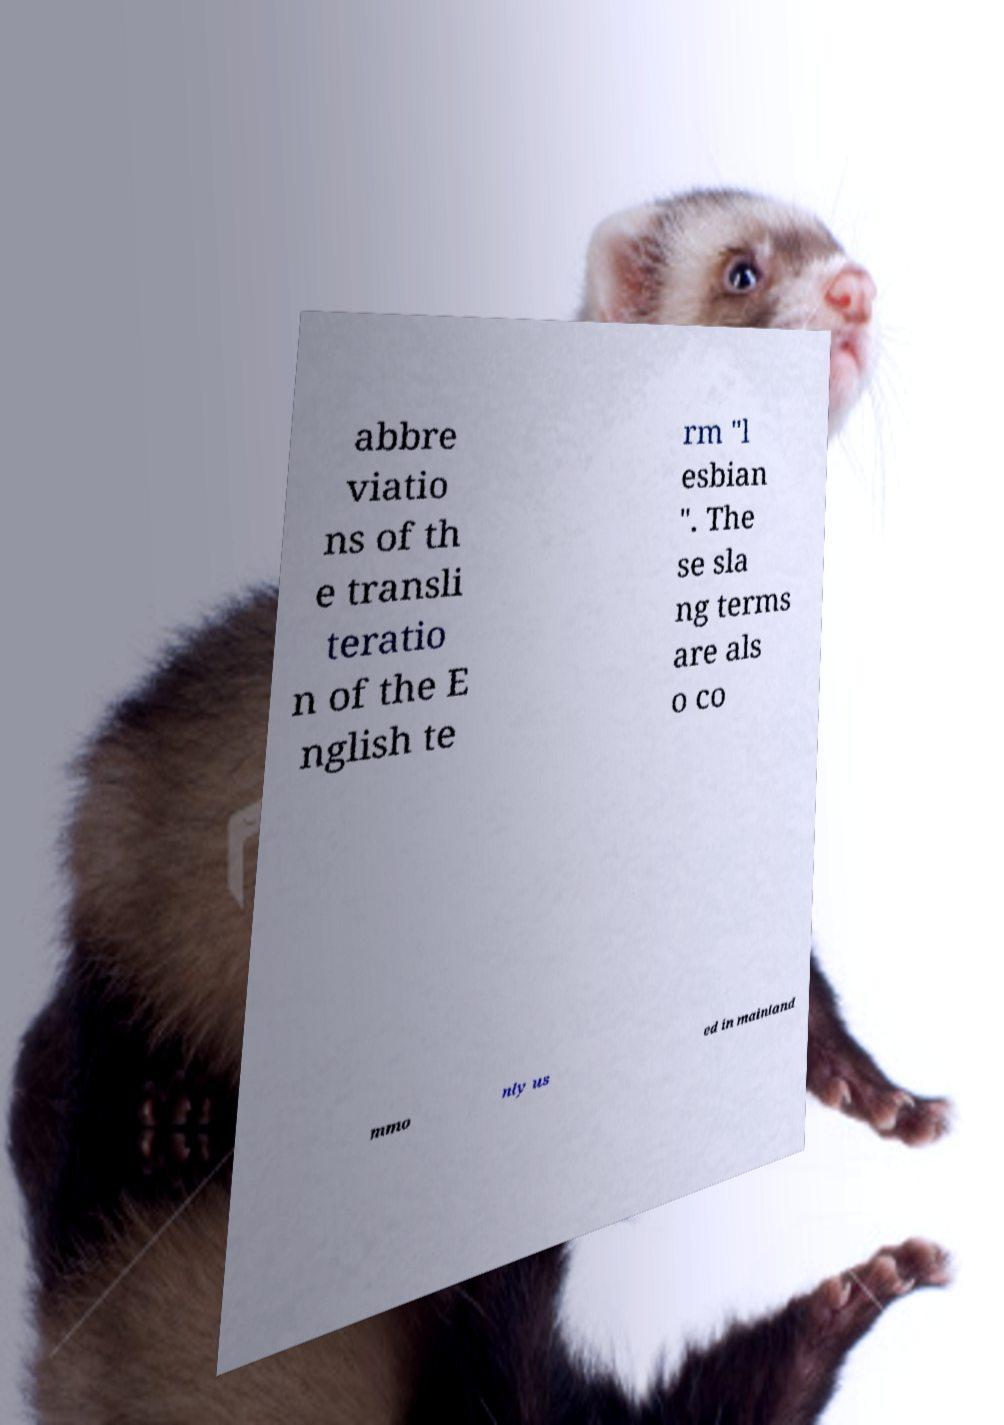Please read and relay the text visible in this image. What does it say? abbre viatio ns of th e transli teratio n of the E nglish te rm "l esbian ". The se sla ng terms are als o co mmo nly us ed in mainland 